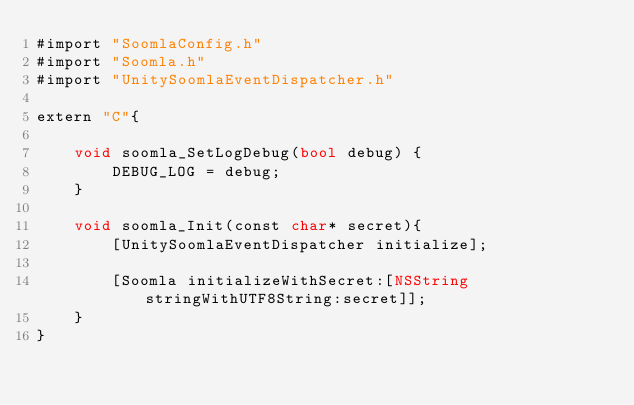<code> <loc_0><loc_0><loc_500><loc_500><_ObjectiveC_>#import "SoomlaConfig.h"
#import "Soomla.h"
#import "UnitySoomlaEventDispatcher.h"

extern "C"{

    void soomla_SetLogDebug(bool debug) {
        DEBUG_LOG = debug;
    }

	void soomla_Init(const char* secret){
        [UnitySoomlaEventDispatcher initialize];
        
		[Soomla initializeWithSecret:[NSString stringWithUTF8String:secret]];
	}
}</code> 